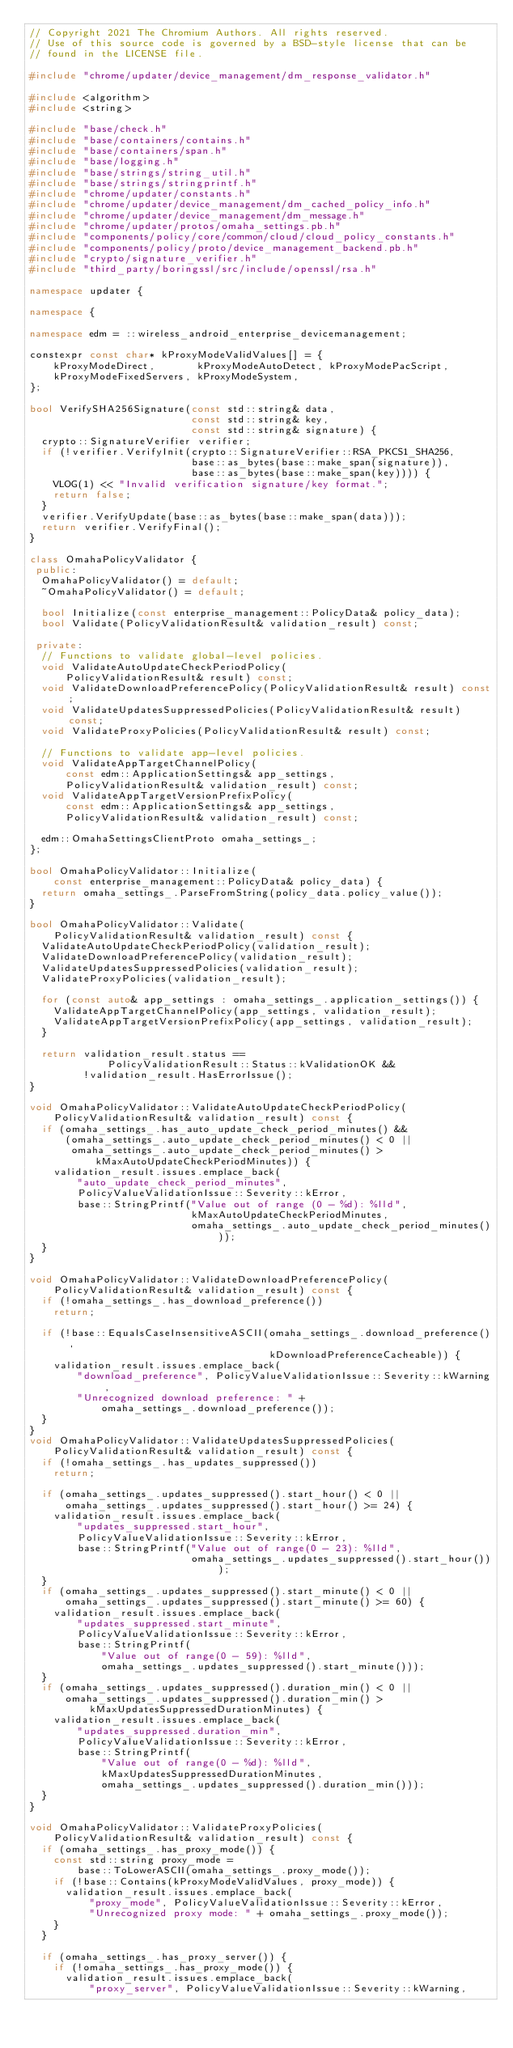Convert code to text. <code><loc_0><loc_0><loc_500><loc_500><_C++_>// Copyright 2021 The Chromium Authors. All rights reserved.
// Use of this source code is governed by a BSD-style license that can be
// found in the LICENSE file.

#include "chrome/updater/device_management/dm_response_validator.h"

#include <algorithm>
#include <string>

#include "base/check.h"
#include "base/containers/contains.h"
#include "base/containers/span.h"
#include "base/logging.h"
#include "base/strings/string_util.h"
#include "base/strings/stringprintf.h"
#include "chrome/updater/constants.h"
#include "chrome/updater/device_management/dm_cached_policy_info.h"
#include "chrome/updater/device_management/dm_message.h"
#include "chrome/updater/protos/omaha_settings.pb.h"
#include "components/policy/core/common/cloud/cloud_policy_constants.h"
#include "components/policy/proto/device_management_backend.pb.h"
#include "crypto/signature_verifier.h"
#include "third_party/boringssl/src/include/openssl/rsa.h"

namespace updater {

namespace {

namespace edm = ::wireless_android_enterprise_devicemanagement;

constexpr const char* kProxyModeValidValues[] = {
    kProxyModeDirect,       kProxyModeAutoDetect, kProxyModePacScript,
    kProxyModeFixedServers, kProxyModeSystem,
};

bool VerifySHA256Signature(const std::string& data,
                           const std::string& key,
                           const std::string& signature) {
  crypto::SignatureVerifier verifier;
  if (!verifier.VerifyInit(crypto::SignatureVerifier::RSA_PKCS1_SHA256,
                           base::as_bytes(base::make_span(signature)),
                           base::as_bytes(base::make_span(key)))) {
    VLOG(1) << "Invalid verification signature/key format.";
    return false;
  }
  verifier.VerifyUpdate(base::as_bytes(base::make_span(data)));
  return verifier.VerifyFinal();
}

class OmahaPolicyValidator {
 public:
  OmahaPolicyValidator() = default;
  ~OmahaPolicyValidator() = default;

  bool Initialize(const enterprise_management::PolicyData& policy_data);
  bool Validate(PolicyValidationResult& validation_result) const;

 private:
  // Functions to validate global-level policies.
  void ValidateAutoUpdateCheckPeriodPolicy(
      PolicyValidationResult& result) const;
  void ValidateDownloadPreferencePolicy(PolicyValidationResult& result) const;
  void ValidateUpdatesSuppressedPolicies(PolicyValidationResult& result) const;
  void ValidateProxyPolicies(PolicyValidationResult& result) const;

  // Functions to validate app-level policies.
  void ValidateAppTargetChannelPolicy(
      const edm::ApplicationSettings& app_settings,
      PolicyValidationResult& validation_result) const;
  void ValidateAppTargetVersionPrefixPolicy(
      const edm::ApplicationSettings& app_settings,
      PolicyValidationResult& validation_result) const;

  edm::OmahaSettingsClientProto omaha_settings_;
};

bool OmahaPolicyValidator::Initialize(
    const enterprise_management::PolicyData& policy_data) {
  return omaha_settings_.ParseFromString(policy_data.policy_value());
}

bool OmahaPolicyValidator::Validate(
    PolicyValidationResult& validation_result) const {
  ValidateAutoUpdateCheckPeriodPolicy(validation_result);
  ValidateDownloadPreferencePolicy(validation_result);
  ValidateUpdatesSuppressedPolicies(validation_result);
  ValidateProxyPolicies(validation_result);

  for (const auto& app_settings : omaha_settings_.application_settings()) {
    ValidateAppTargetChannelPolicy(app_settings, validation_result);
    ValidateAppTargetVersionPrefixPolicy(app_settings, validation_result);
  }

  return validation_result.status ==
             PolicyValidationResult::Status::kValidationOK &&
         !validation_result.HasErrorIssue();
}

void OmahaPolicyValidator::ValidateAutoUpdateCheckPeriodPolicy(
    PolicyValidationResult& validation_result) const {
  if (omaha_settings_.has_auto_update_check_period_minutes() &&
      (omaha_settings_.auto_update_check_period_minutes() < 0 ||
       omaha_settings_.auto_update_check_period_minutes() >
           kMaxAutoUpdateCheckPeriodMinutes)) {
    validation_result.issues.emplace_back(
        "auto_update_check_period_minutes",
        PolicyValueValidationIssue::Severity::kError,
        base::StringPrintf("Value out of range (0 - %d): %lld",
                           kMaxAutoUpdateCheckPeriodMinutes,
                           omaha_settings_.auto_update_check_period_minutes()));
  }
}

void OmahaPolicyValidator::ValidateDownloadPreferencePolicy(
    PolicyValidationResult& validation_result) const {
  if (!omaha_settings_.has_download_preference())
    return;

  if (!base::EqualsCaseInsensitiveASCII(omaha_settings_.download_preference(),
                                        kDownloadPreferenceCacheable)) {
    validation_result.issues.emplace_back(
        "download_preference", PolicyValueValidationIssue::Severity::kWarning,
        "Unrecognized download preference: " +
            omaha_settings_.download_preference());
  }
}
void OmahaPolicyValidator::ValidateUpdatesSuppressedPolicies(
    PolicyValidationResult& validation_result) const {
  if (!omaha_settings_.has_updates_suppressed())
    return;

  if (omaha_settings_.updates_suppressed().start_hour() < 0 ||
      omaha_settings_.updates_suppressed().start_hour() >= 24) {
    validation_result.issues.emplace_back(
        "updates_suppressed.start_hour",
        PolicyValueValidationIssue::Severity::kError,
        base::StringPrintf("Value out of range(0 - 23): %lld",
                           omaha_settings_.updates_suppressed().start_hour()));
  }
  if (omaha_settings_.updates_suppressed().start_minute() < 0 ||
      omaha_settings_.updates_suppressed().start_minute() >= 60) {
    validation_result.issues.emplace_back(
        "updates_suppressed.start_minute",
        PolicyValueValidationIssue::Severity::kError,
        base::StringPrintf(
            "Value out of range(0 - 59): %lld",
            omaha_settings_.updates_suppressed().start_minute()));
  }
  if (omaha_settings_.updates_suppressed().duration_min() < 0 ||
      omaha_settings_.updates_suppressed().duration_min() >
          kMaxUpdatesSuppressedDurationMinutes) {
    validation_result.issues.emplace_back(
        "updates_suppressed.duration_min",
        PolicyValueValidationIssue::Severity::kError,
        base::StringPrintf(
            "Value out of range(0 - %d): %lld",
            kMaxUpdatesSuppressedDurationMinutes,
            omaha_settings_.updates_suppressed().duration_min()));
  }
}

void OmahaPolicyValidator::ValidateProxyPolicies(
    PolicyValidationResult& validation_result) const {
  if (omaha_settings_.has_proxy_mode()) {
    const std::string proxy_mode =
        base::ToLowerASCII(omaha_settings_.proxy_mode());
    if (!base::Contains(kProxyModeValidValues, proxy_mode)) {
      validation_result.issues.emplace_back(
          "proxy_mode", PolicyValueValidationIssue::Severity::kError,
          "Unrecognized proxy mode: " + omaha_settings_.proxy_mode());
    }
  }

  if (omaha_settings_.has_proxy_server()) {
    if (!omaha_settings_.has_proxy_mode()) {
      validation_result.issues.emplace_back(
          "proxy_server", PolicyValueValidationIssue::Severity::kWarning,</code> 